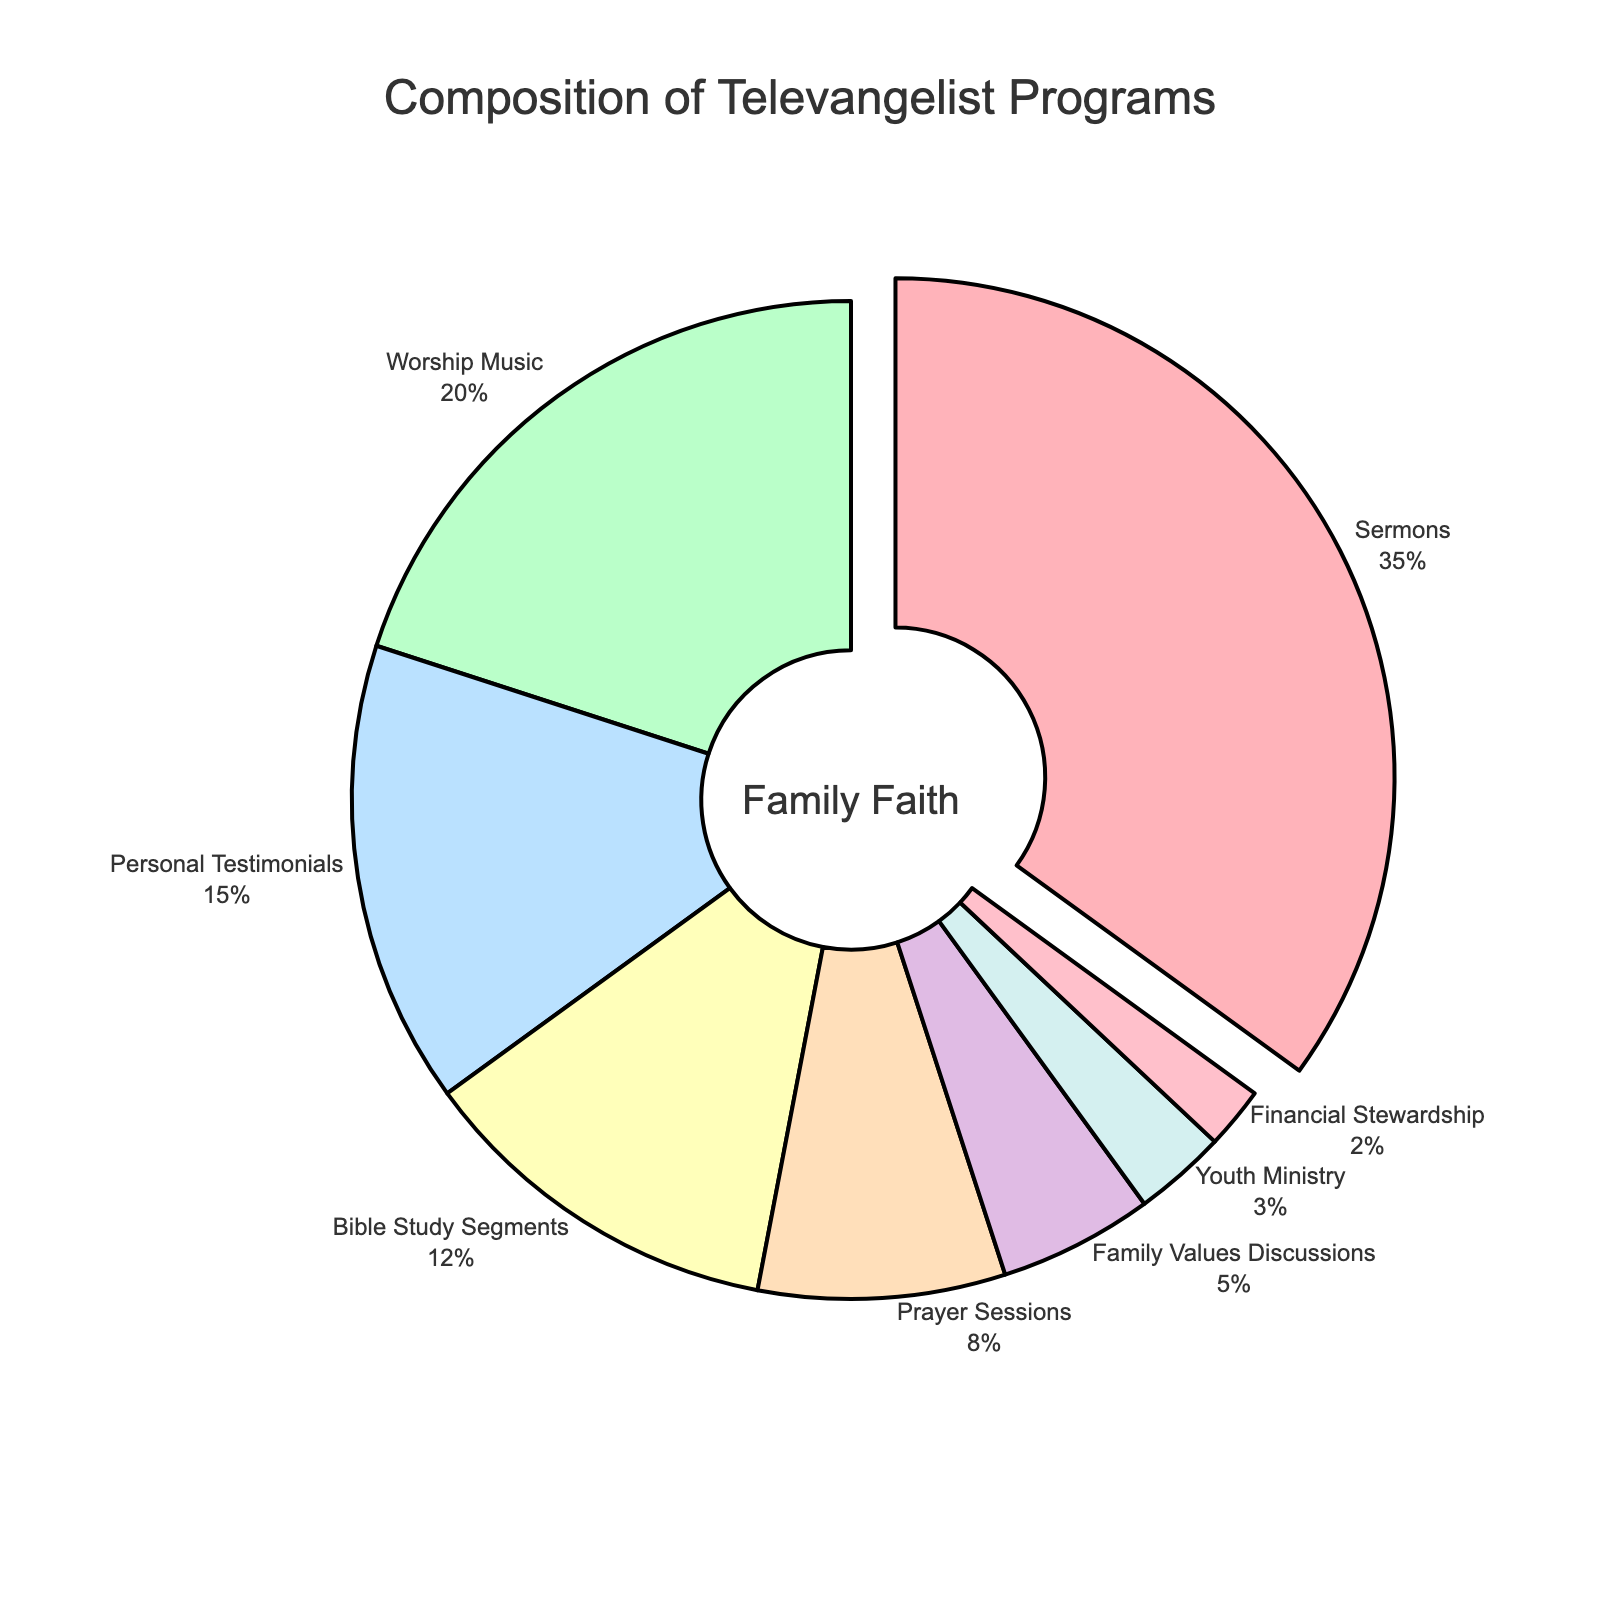What percentage of the programs is dedicated to both Sermons and Worship Music combined? The percentages of Sermons and Worship Music are given as 35% and 20% respectively. Adding these together gives 35 + 20 = 55%.
Answer: 55% Which content type has the least representation in the programs? By observing the percentages, Financial Stewardship has the lowest value at 2%.
Answer: Financial Stewardship Which content category has a larger share, Prayer Sessions or Family Values Discussions? The percentage for Prayer Sessions is 8%, and for Family Values Discussions, it is 5%. Since 8% is larger than 5%, Prayer Sessions has a larger share.
Answer: Prayer Sessions What is the difference in percentage between Sermons and Bible Study Segments? Sermons account for 35% and Bible Study Segments for 12%. The difference is calculated as 35% - 12% = 23%.
Answer: 23% How much more percentage does Worship Music represent compared to Youth Ministry? Worship Music represents 20%, and Youth Ministry represents 3%. The difference is 20% - 3% = 17%.
Answer: 17% If you combine Personal Testimonials, Bible Study Segments, and Prayer Sessions, what percentage of the total does this combination represent? The percentages for Personal Testimonials, Bible Study Segments, and Prayer Sessions are 15%, 12%, and 8% respectively. Summing them gives 15 + 12 + 8 = 35%.
Answer: 35% Which type of content is visually distinguished by being pulled out slightly from the pie chart? Observing the visualization, the slice that is pulled out slightly is the one representing the Sermons, as it has the highest percentage.
Answer: Sermons What is the combined percentage of programs focused on family and youth matters (Family Values Discussions and Youth Ministry)? The percentages for Family Values Discussions and Youth Ministry are 5% and 3% respectively. Adding these together gives 5 + 3 = 8%.
Answer: 8% What type of content is indicated with the color that appears closest to pink? By observing the colors associated with the categories, Worship Music, which is represented by a closest-to-pink color, can be inferred visually.
Answer: Worship Music 